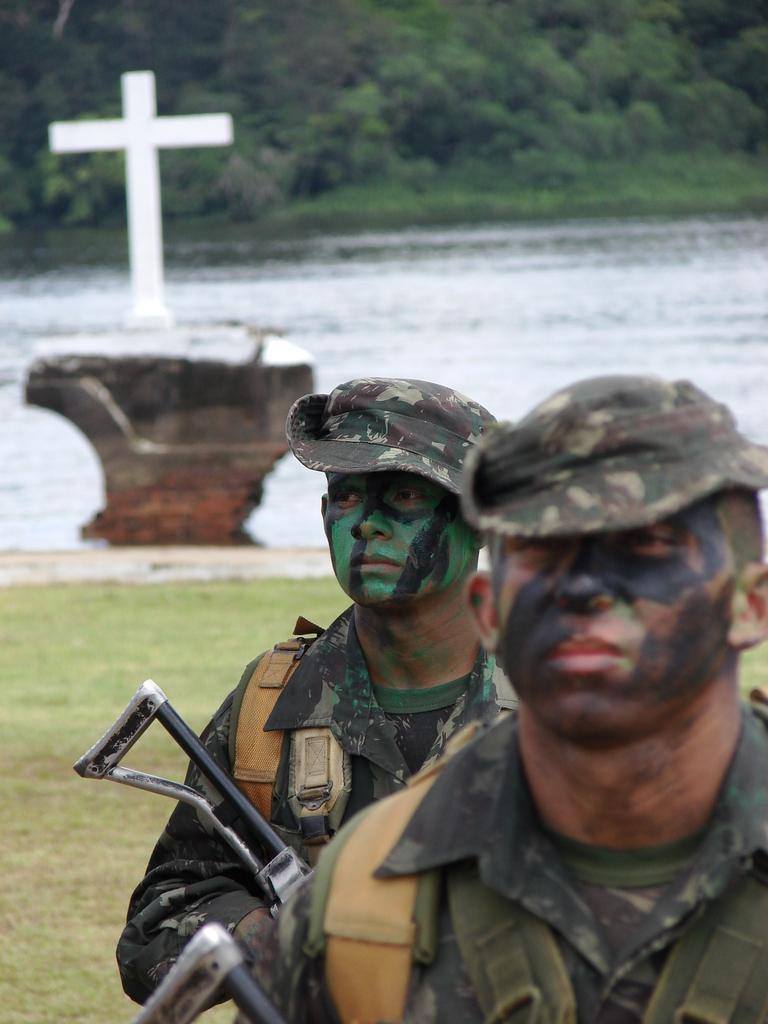How many people are in the image? There are two men in the image. What are the men holding in the image? The men are holding guns. What type of natural environment can be seen in the image? There is grass, water, and trees visible in the image. What is the religious symbol present in the image? There is a cross in the image. Is there a beggar asking for money in the image? There is no beggar present in the image. What type of expert is shown giving a lecture in the image? There is no expert present in the image. 